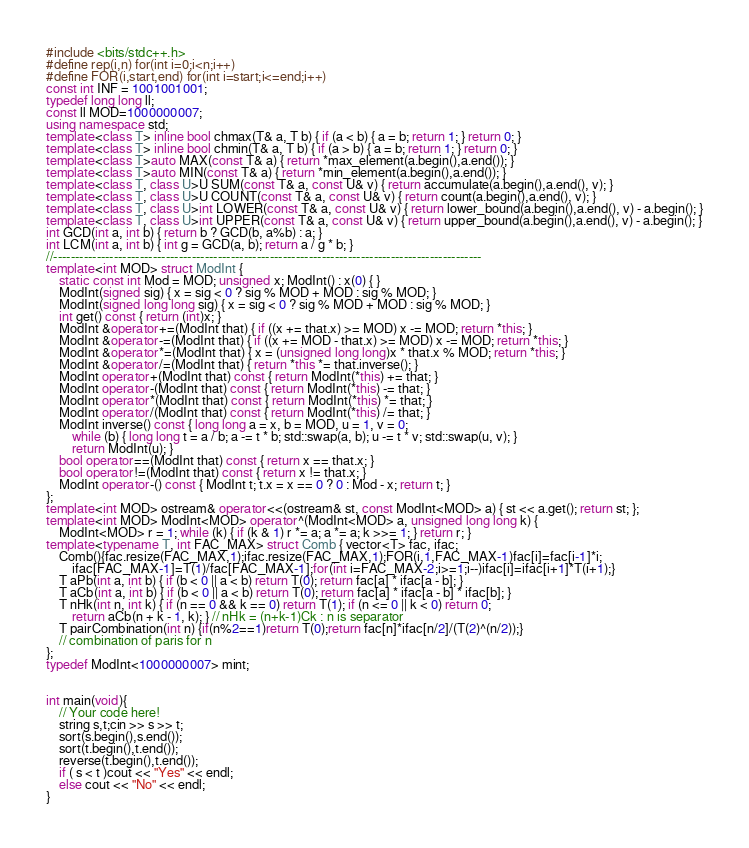<code> <loc_0><loc_0><loc_500><loc_500><_C++_>#include <bits/stdc++.h>
#define rep(i,n) for(int i=0;i<n;i++)
#define FOR(i,start,end) for(int i=start;i<=end;i++)
const int INF = 1001001001;
typedef long long ll;
const ll MOD=1000000007;
using namespace std;
template<class T> inline bool chmax(T& a, T b) { if (a < b) { a = b; return 1; } return 0; }
template<class T> inline bool chmin(T& a, T b) { if (a > b) { a = b; return 1; } return 0; }
template<class T>auto MAX(const T& a) { return *max_element(a.begin(),a.end()); }
template<class T>auto MIN(const T& a) { return *min_element(a.begin(),a.end()); }
template<class T, class U>U SUM(const T& a, const U& v) { return accumulate(a.begin(),a.end(), v); }
template<class T, class U>U COUNT(const T& a, const U& v) { return count(a.begin(),a.end(), v); }
template<class T, class U>int LOWER(const T& a, const U& v) { return lower_bound(a.begin(),a.end(), v) - a.begin(); }
template<class T, class U>int UPPER(const T& a, const U& v) { return upper_bound(a.begin(),a.end(), v) - a.begin(); }
int GCD(int a, int b) { return b ? GCD(b, a%b) : a; }
int LCM(int a, int b) { int g = GCD(a, b); return a / g * b; }
//---------------------------------------------------------------------------------------------------
template<int MOD> struct ModInt {
    static const int Mod = MOD; unsigned x; ModInt() : x(0) { }
    ModInt(signed sig) { x = sig < 0 ? sig % MOD + MOD : sig % MOD; }
    ModInt(signed long long sig) { x = sig < 0 ? sig % MOD + MOD : sig % MOD; }
    int get() const { return (int)x; }
    ModInt &operator+=(ModInt that) { if ((x += that.x) >= MOD) x -= MOD; return *this; }
    ModInt &operator-=(ModInt that) { if ((x += MOD - that.x) >= MOD) x -= MOD; return *this; }
    ModInt &operator*=(ModInt that) { x = (unsigned long long)x * that.x % MOD; return *this; }
    ModInt &operator/=(ModInt that) { return *this *= that.inverse(); }
    ModInt operator+(ModInt that) const { return ModInt(*this) += that; }
    ModInt operator-(ModInt that) const { return ModInt(*this) -= that; }
    ModInt operator*(ModInt that) const { return ModInt(*this) *= that; }
    ModInt operator/(ModInt that) const { return ModInt(*this) /= that; }
    ModInt inverse() const { long long a = x, b = MOD, u = 1, v = 0;
        while (b) { long long t = a / b; a -= t * b; std::swap(a, b); u -= t * v; std::swap(u, v); }
        return ModInt(u); }
    bool operator==(ModInt that) const { return x == that.x; }
    bool operator!=(ModInt that) const { return x != that.x; }
    ModInt operator-() const { ModInt t; t.x = x == 0 ? 0 : Mod - x; return t; }
};
template<int MOD> ostream& operator<<(ostream& st, const ModInt<MOD> a) { st << a.get(); return st; };
template<int MOD> ModInt<MOD> operator^(ModInt<MOD> a, unsigned long long k) {
    ModInt<MOD> r = 1; while (k) { if (k & 1) r *= a; a *= a; k >>= 1; } return r; }
template<typename T, int FAC_MAX> struct Comb { vector<T> fac, ifac;
    Comb(){fac.resize(FAC_MAX,1);ifac.resize(FAC_MAX,1);FOR(i,1,FAC_MAX-1)fac[i]=fac[i-1]*i;
        ifac[FAC_MAX-1]=T(1)/fac[FAC_MAX-1];for(int i=FAC_MAX-2;i>=1;i--)ifac[i]=ifac[i+1]*T(i+1);}
    T aPb(int a, int b) { if (b < 0 || a < b) return T(0); return fac[a] * ifac[a - b]; }
    T aCb(int a, int b) { if (b < 0 || a < b) return T(0); return fac[a] * ifac[a - b] * ifac[b]; }
    T nHk(int n, int k) { if (n == 0 && k == 0) return T(1); if (n <= 0 || k < 0) return 0;
        return aCb(n + k - 1, k); } // nHk = (n+k-1)Ck : n is separator
    T pairCombination(int n) {if(n%2==1)return T(0);return fac[n]*ifac[n/2]/(T(2)^(n/2));}
    // combination of paris for n
}; 
typedef ModInt<1000000007> mint;


int main(void){
    // Your code here!
    string s,t;cin >> s >> t;
    sort(s.begin(),s.end());
    sort(t.begin(),t.end());
    reverse(t.begin(),t.end());
    if ( s < t )cout << "Yes" << endl;
    else cout << "No" << endl;
}
</code> 